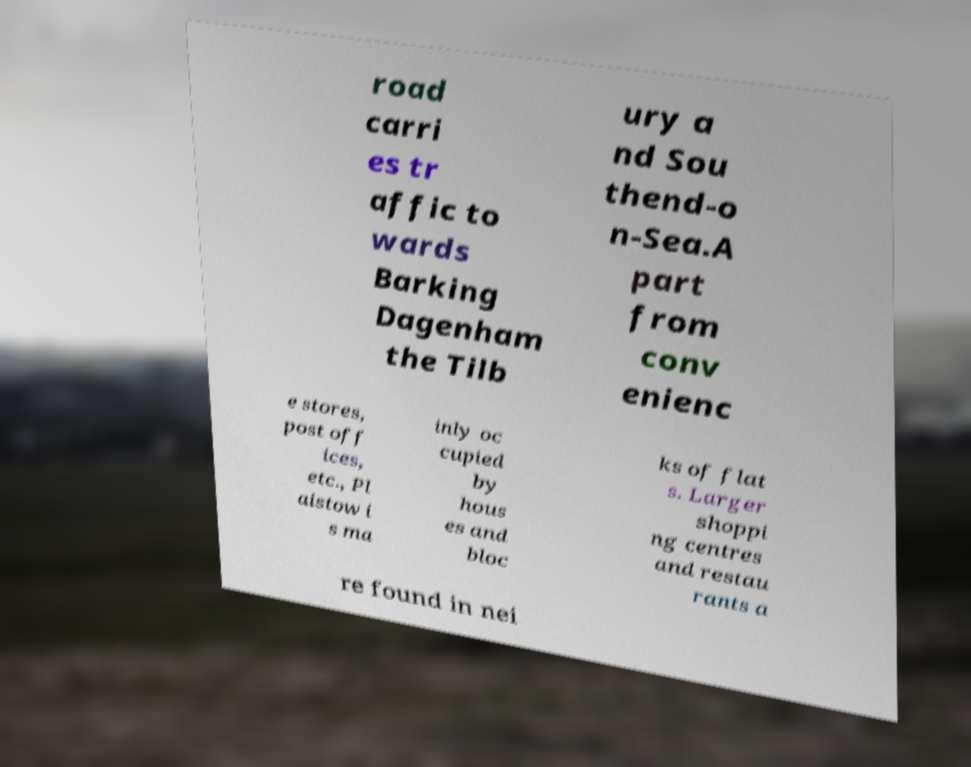Can you read and provide the text displayed in the image?This photo seems to have some interesting text. Can you extract and type it out for me? road carri es tr affic to wards Barking Dagenham the Tilb ury a nd Sou thend-o n-Sea.A part from conv enienc e stores, post off ices, etc., Pl aistow i s ma inly oc cupied by hous es and bloc ks of flat s. Larger shoppi ng centres and restau rants a re found in nei 